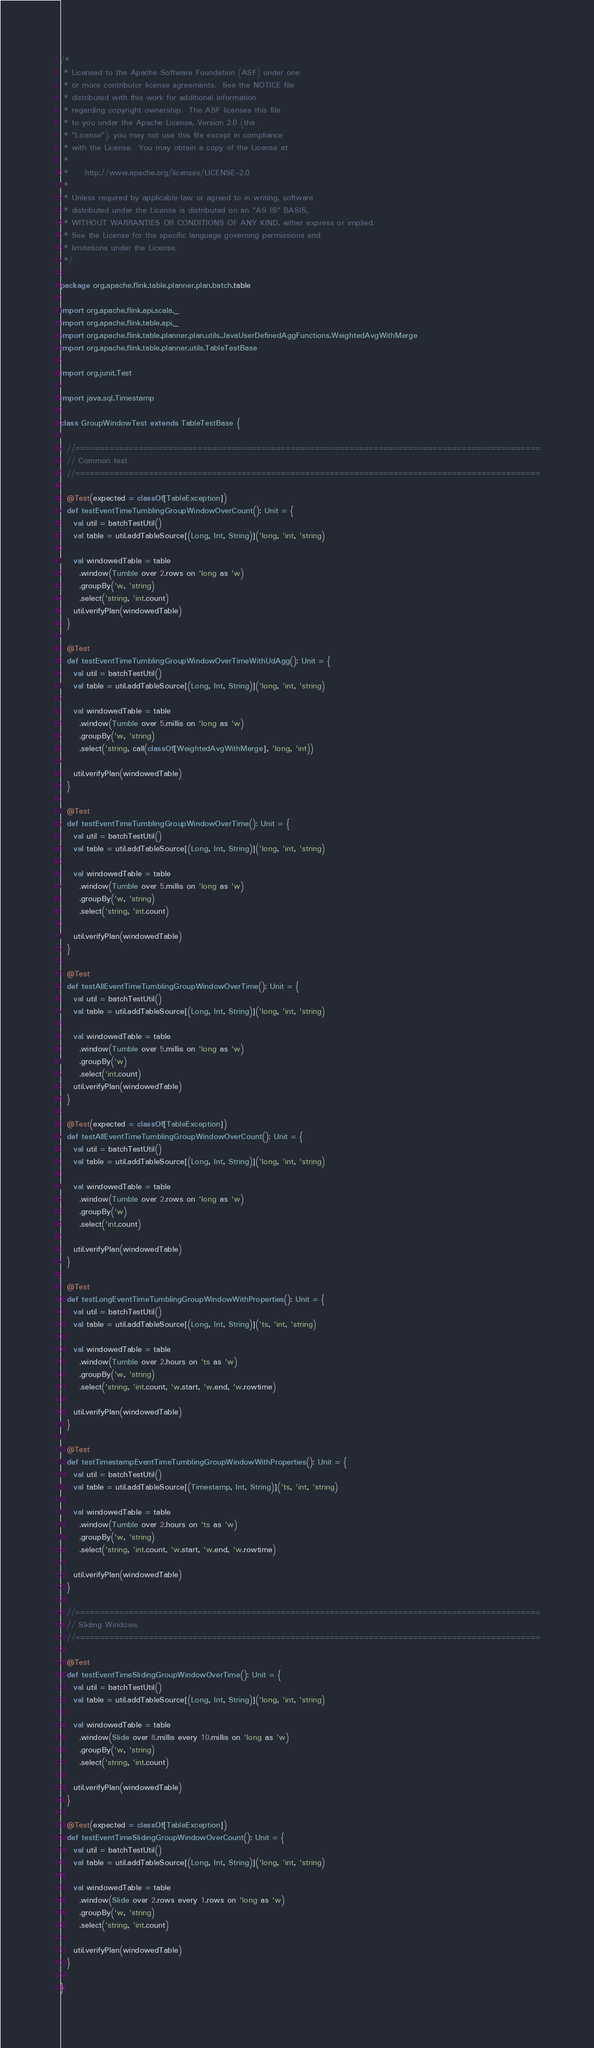<code> <loc_0><loc_0><loc_500><loc_500><_Scala_>/*
 * Licensed to the Apache Software Foundation (ASF) under one
 * or more contributor license agreements.  See the NOTICE file
 * distributed with this work for additional information
 * regarding copyright ownership.  The ASF licenses this file
 * to you under the Apache License, Version 2.0 (the
 * "License"); you may not use this file except in compliance
 * with the License.  You may obtain a copy of the License at
 *
 *     http://www.apache.org/licenses/LICENSE-2.0
 *
 * Unless required by applicable law or agreed to in writing, software
 * distributed under the License is distributed on an "AS IS" BASIS,
 * WITHOUT WARRANTIES OR CONDITIONS OF ANY KIND, either express or implied.
 * See the License for the specific language governing permissions and
 * limitations under the License.
 */

package org.apache.flink.table.planner.plan.batch.table

import org.apache.flink.api.scala._
import org.apache.flink.table.api._
import org.apache.flink.table.planner.plan.utils.JavaUserDefinedAggFunctions.WeightedAvgWithMerge
import org.apache.flink.table.planner.utils.TableTestBase

import org.junit.Test

import java.sql.Timestamp

class GroupWindowTest extends TableTestBase {

  //===============================================================================================
  // Common test
  //===============================================================================================

  @Test(expected = classOf[TableException])
  def testEventTimeTumblingGroupWindowOverCount(): Unit = {
    val util = batchTestUtil()
    val table = util.addTableSource[(Long, Int, String)]('long, 'int, 'string)

    val windowedTable = table
      .window(Tumble over 2.rows on 'long as 'w)
      .groupBy('w, 'string)
      .select('string, 'int.count)
    util.verifyPlan(windowedTable)
  }

  @Test
  def testEventTimeTumblingGroupWindowOverTimeWithUdAgg(): Unit = {
    val util = batchTestUtil()
    val table = util.addTableSource[(Long, Int, String)]('long, 'int, 'string)

    val windowedTable = table
      .window(Tumble over 5.millis on 'long as 'w)
      .groupBy('w, 'string)
      .select('string, call(classOf[WeightedAvgWithMerge], 'long, 'int))

    util.verifyPlan(windowedTable)
  }

  @Test
  def testEventTimeTumblingGroupWindowOverTime(): Unit = {
    val util = batchTestUtil()
    val table = util.addTableSource[(Long, Int, String)]('long, 'int, 'string)

    val windowedTable = table
      .window(Tumble over 5.millis on 'long as 'w)
      .groupBy('w, 'string)
      .select('string, 'int.count)

    util.verifyPlan(windowedTable)
  }

  @Test
  def testAllEventTimeTumblingGroupWindowOverTime(): Unit = {
    val util = batchTestUtil()
    val table = util.addTableSource[(Long, Int, String)]('long, 'int, 'string)

    val windowedTable = table
      .window(Tumble over 5.millis on 'long as 'w)
      .groupBy('w)
      .select('int.count)
    util.verifyPlan(windowedTable)
  }

  @Test(expected = classOf[TableException])
  def testAllEventTimeTumblingGroupWindowOverCount(): Unit = {
    val util = batchTestUtil()
    val table = util.addTableSource[(Long, Int, String)]('long, 'int, 'string)

    val windowedTable = table
      .window(Tumble over 2.rows on 'long as 'w)
      .groupBy('w)
      .select('int.count)

    util.verifyPlan(windowedTable)
  }

  @Test
  def testLongEventTimeTumblingGroupWindowWithProperties(): Unit = {
    val util = batchTestUtil()
    val table = util.addTableSource[(Long, Int, String)]('ts, 'int, 'string)

    val windowedTable = table
      .window(Tumble over 2.hours on 'ts as 'w)
      .groupBy('w, 'string)
      .select('string, 'int.count, 'w.start, 'w.end, 'w.rowtime)

    util.verifyPlan(windowedTable)
  }

  @Test
  def testTimestampEventTimeTumblingGroupWindowWithProperties(): Unit = {
    val util = batchTestUtil()
    val table = util.addTableSource[(Timestamp, Int, String)]('ts, 'int, 'string)

    val windowedTable = table
      .window(Tumble over 2.hours on 'ts as 'w)
      .groupBy('w, 'string)
      .select('string, 'int.count, 'w.start, 'w.end, 'w.rowtime)

    util.verifyPlan(windowedTable)
  }

  //===============================================================================================
  // Sliding Windows
  //===============================================================================================

  @Test
  def testEventTimeSlidingGroupWindowOverTime(): Unit = {
    val util = batchTestUtil()
    val table = util.addTableSource[(Long, Int, String)]('long, 'int, 'string)

    val windowedTable = table
      .window(Slide over 8.millis every 10.millis on 'long as 'w)
      .groupBy('w, 'string)
      .select('string, 'int.count)

    util.verifyPlan(windowedTable)
  }

  @Test(expected = classOf[TableException])
  def testEventTimeSlidingGroupWindowOverCount(): Unit = {
    val util = batchTestUtil()
    val table = util.addTableSource[(Long, Int, String)]('long, 'int, 'string)

    val windowedTable = table
      .window(Slide over 2.rows every 1.rows on 'long as 'w)
      .groupBy('w, 'string)
      .select('string, 'int.count)

    util.verifyPlan(windowedTable)
  }

}
</code> 